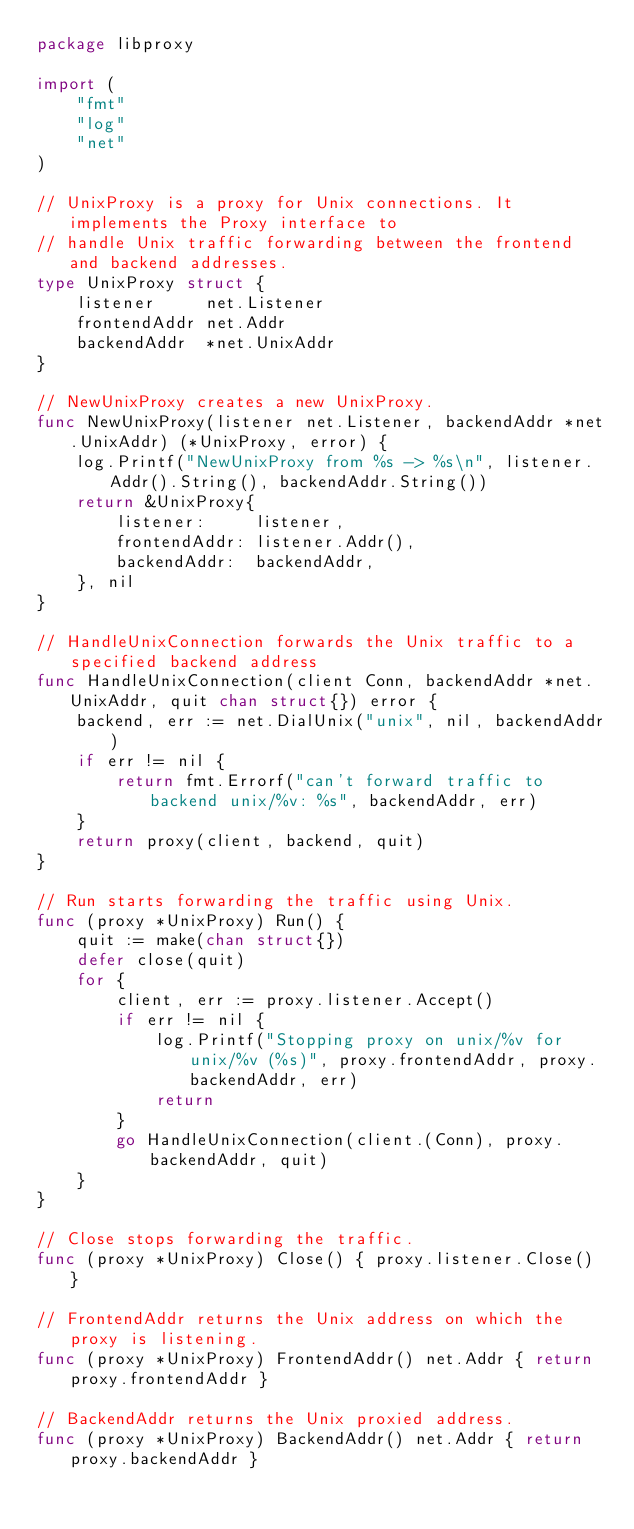<code> <loc_0><loc_0><loc_500><loc_500><_Go_>package libproxy

import (
	"fmt"
	"log"
	"net"
)

// UnixProxy is a proxy for Unix connections. It implements the Proxy interface to
// handle Unix traffic forwarding between the frontend and backend addresses.
type UnixProxy struct {
	listener     net.Listener
	frontendAddr net.Addr
	backendAddr  *net.UnixAddr
}

// NewUnixProxy creates a new UnixProxy.
func NewUnixProxy(listener net.Listener, backendAddr *net.UnixAddr) (*UnixProxy, error) {
	log.Printf("NewUnixProxy from %s -> %s\n", listener.Addr().String(), backendAddr.String())
	return &UnixProxy{
		listener:     listener,
		frontendAddr: listener.Addr(),
		backendAddr:  backendAddr,
	}, nil
}

// HandleUnixConnection forwards the Unix traffic to a specified backend address
func HandleUnixConnection(client Conn, backendAddr *net.UnixAddr, quit chan struct{}) error {
	backend, err := net.DialUnix("unix", nil, backendAddr)
	if err != nil {
		return fmt.Errorf("can't forward traffic to backend unix/%v: %s", backendAddr, err)
	}
	return proxy(client, backend, quit)
}

// Run starts forwarding the traffic using Unix.
func (proxy *UnixProxy) Run() {
	quit := make(chan struct{})
	defer close(quit)
	for {
		client, err := proxy.listener.Accept()
		if err != nil {
			log.Printf("Stopping proxy on unix/%v for unix/%v (%s)", proxy.frontendAddr, proxy.backendAddr, err)
			return
		}
		go HandleUnixConnection(client.(Conn), proxy.backendAddr, quit)
	}
}

// Close stops forwarding the traffic.
func (proxy *UnixProxy) Close() { proxy.listener.Close() }

// FrontendAddr returns the Unix address on which the proxy is listening.
func (proxy *UnixProxy) FrontendAddr() net.Addr { return proxy.frontendAddr }

// BackendAddr returns the Unix proxied address.
func (proxy *UnixProxy) BackendAddr() net.Addr { return proxy.backendAddr }
</code> 